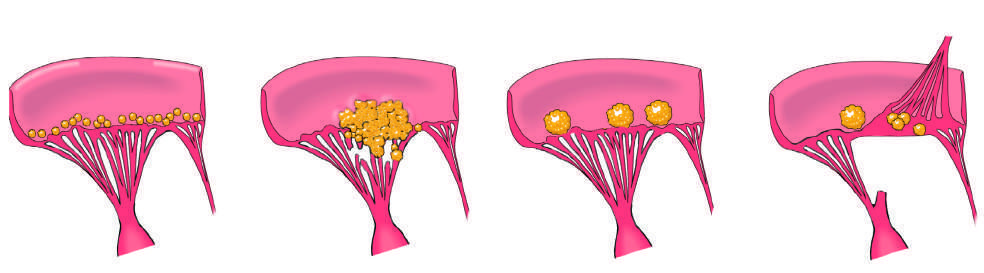re some long-lived resident tissue macrophages marked by the appearance of small, warty, inflammatory vegetations along the lines of valve closure?
Answer the question using a single word or phrase. No 